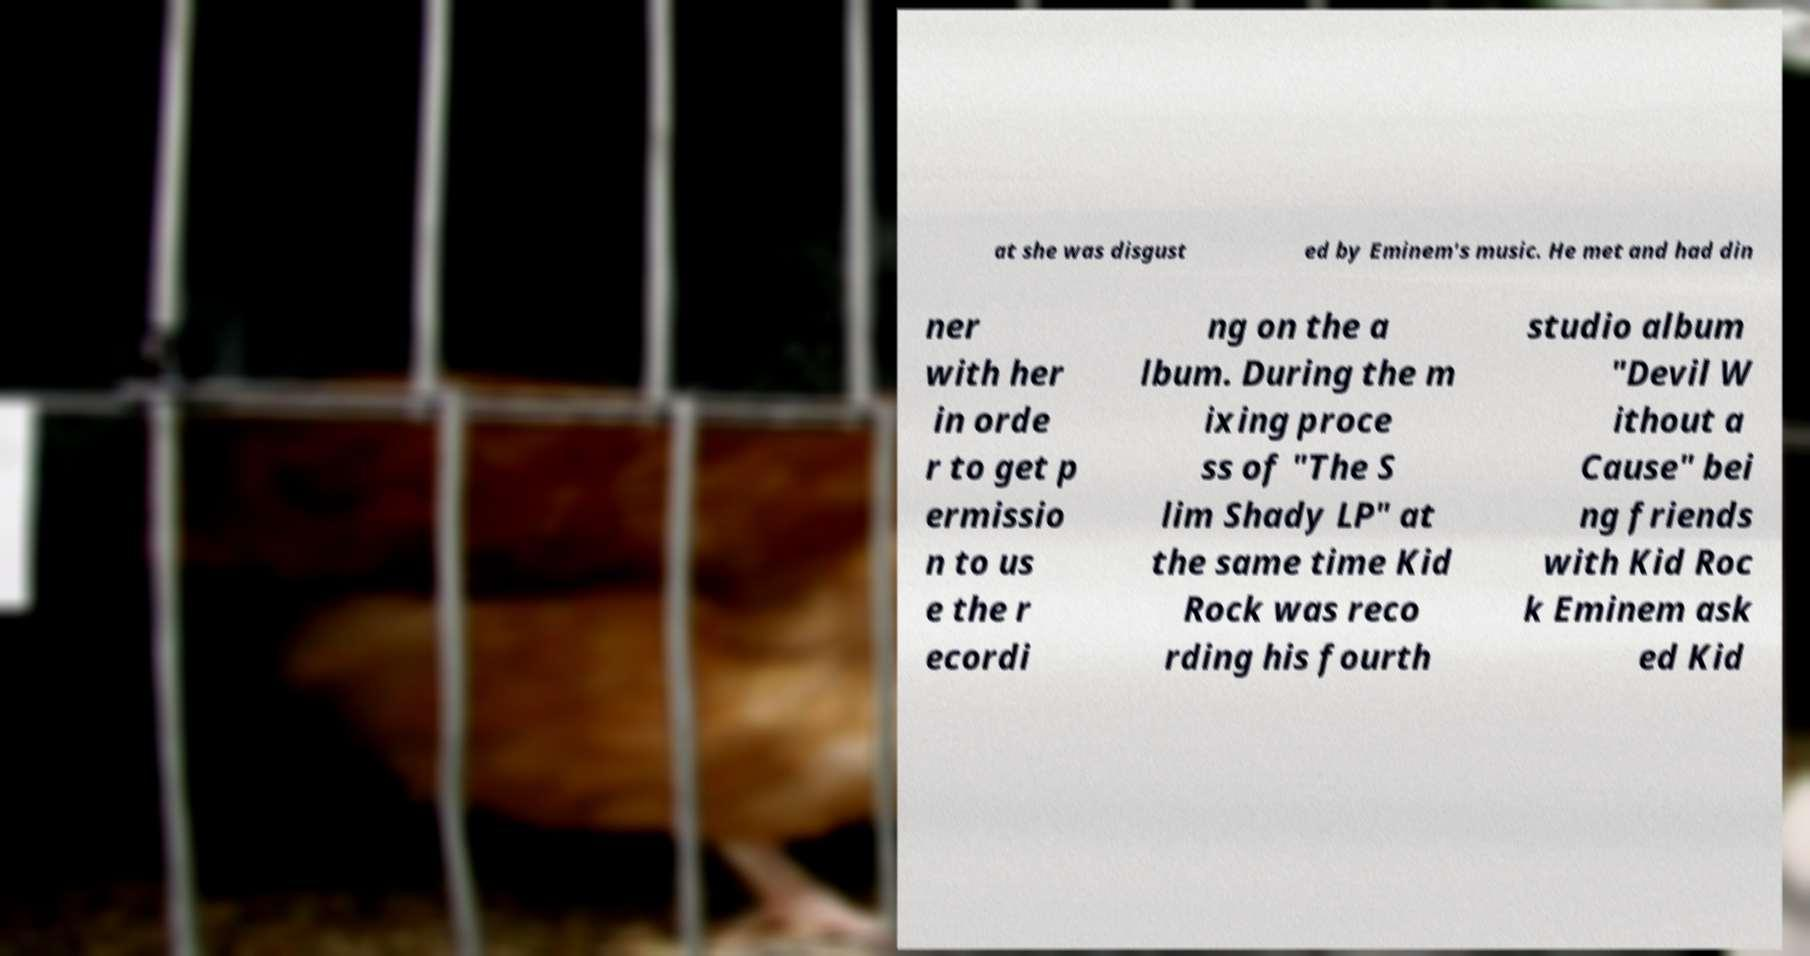Can you accurately transcribe the text from the provided image for me? at she was disgust ed by Eminem's music. He met and had din ner with her in orde r to get p ermissio n to us e the r ecordi ng on the a lbum. During the m ixing proce ss of "The S lim Shady LP" at the same time Kid Rock was reco rding his fourth studio album "Devil W ithout a Cause" bei ng friends with Kid Roc k Eminem ask ed Kid 